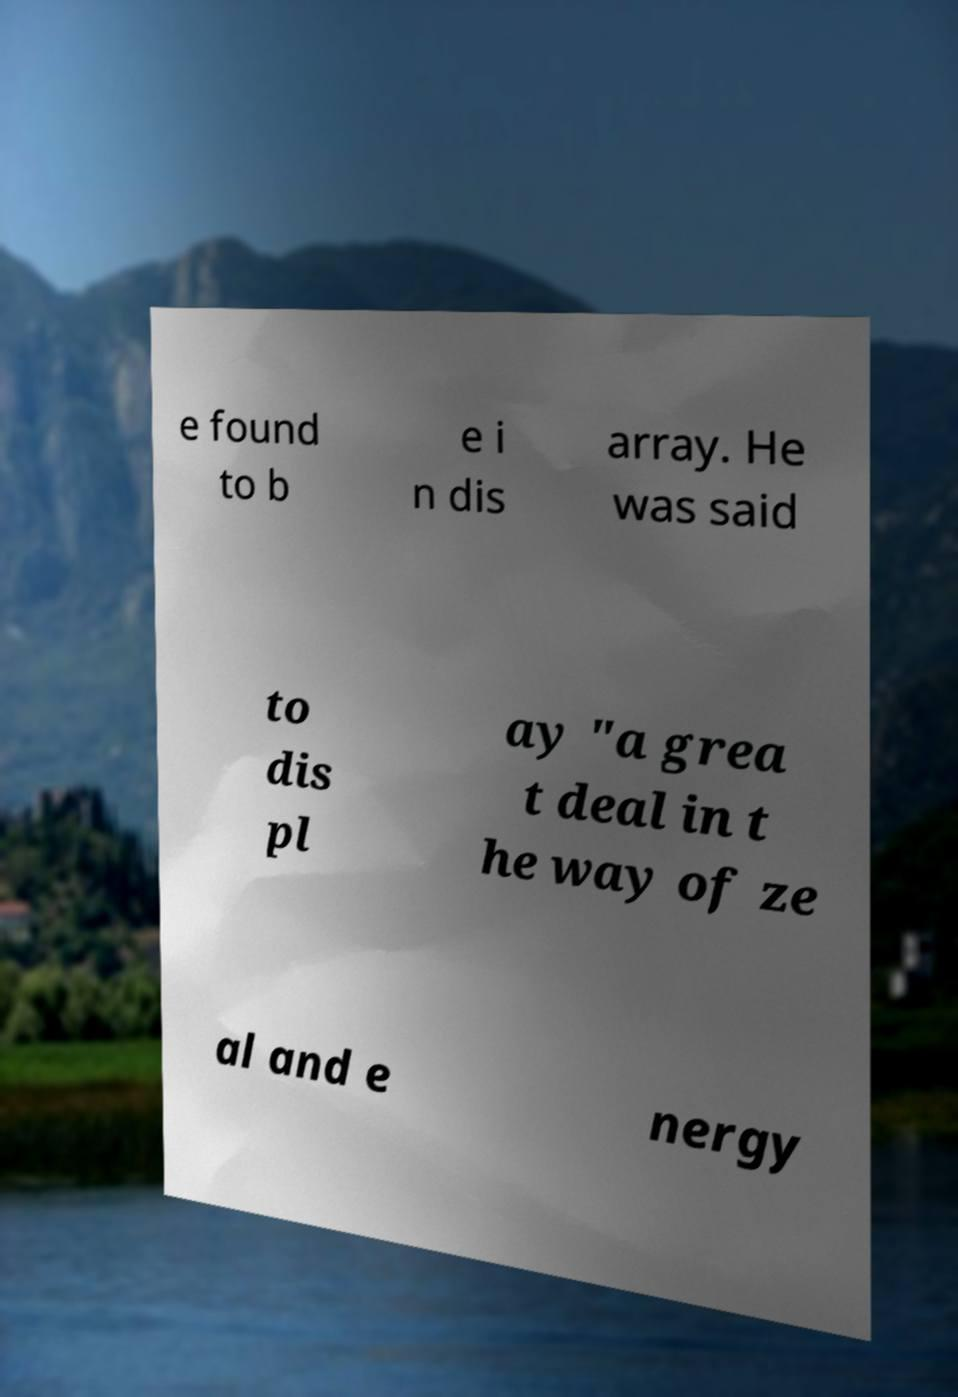Please identify and transcribe the text found in this image. e found to b e i n dis array. He was said to dis pl ay "a grea t deal in t he way of ze al and e nergy 